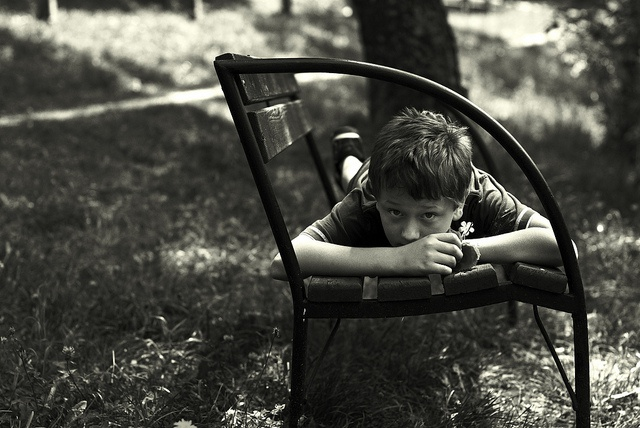Describe the objects in this image and their specific colors. I can see bench in black, gray, ivory, and darkgray tones and people in black, gray, ivory, and darkgray tones in this image. 